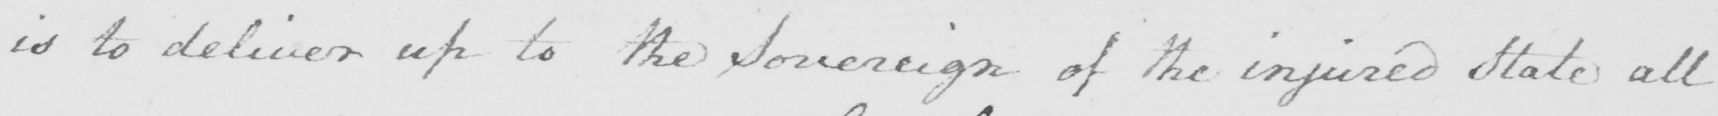What does this handwritten line say? is to deliver up to the Sovereign of the injured State all 